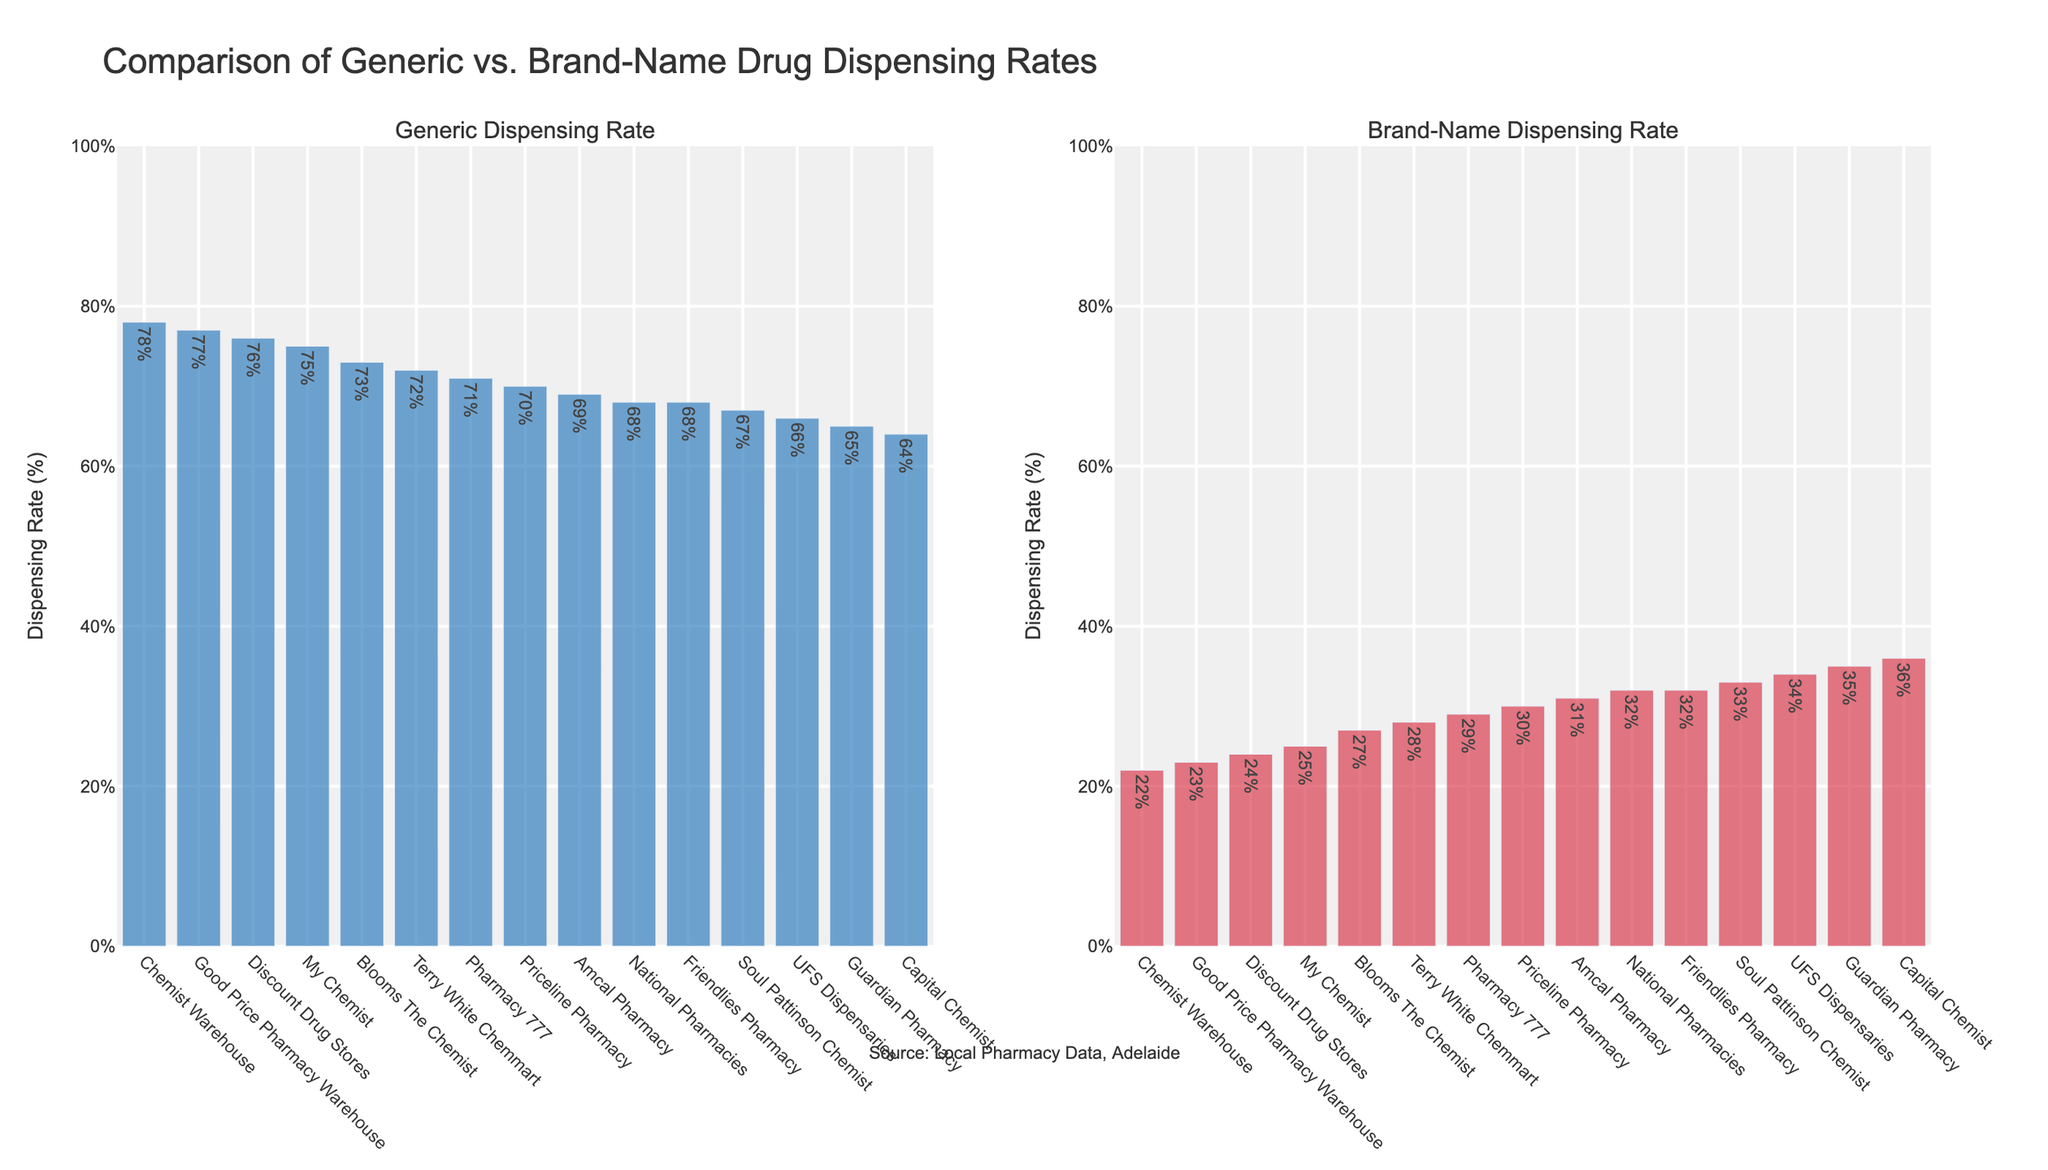What is the pharmacy chain with the highest generic dispensing rate? Look at the first bar in the 'Generic Dispensing Rate' subplot, which represents the highest rate.
Answer: Chemist Warehouse What is the difference in the generic dispensing rates between Chemist Warehouse and Guardian Pharmacy? Chemist Warehouse has a rate of 78% and Guardian Pharmacy has a rate of 65%. The difference is 78% - 65% = 13%.
Answer: 13% Which has a higher brand-name dispensing rate, Amcal Pharmacy or UFS Dispensaries? Compare the heights of the bars in the 'Brand-Name Dispensing Rate' subplot for Amcal Pharmacy and UFS Dispensaries. UFS Dispensaries have a higher rate.
Answer: UFS Dispensaries What is the average generic dispensing rate across all pharmacy chains? Sum all the generic dispensing rates and divide by the number of chains (15). (78+72+70+68+76+65+67+69+71+75+66+64+77+73+68) / 15 = 71%
Answer: 71% Which pharmacy chain has a higher generic dispensing rate than Priceline Pharmacy but a lower rate than Terry White Chemmart? Priceline Pharmacy has a rate of 70% and Terry White Chemmart has a rate of 72%. Find the bar that fits between these rates in the 'Generic Dispensing Rate' subplot, which is Amcal Pharmacy with 69%.
Answer: Amcal Pharmacy What is the total brand-name dispensing rate for Discount Drug Stores, My Chemist, and Good Price Pharmacy Warehouse? Sum the individual brand-name dispensing rates: 24% + 25% + 23% = 72%.
Answer: 72% Is there any pharmacy chain with a brand-name dispensing rate equal to 30%? Examine each bar in the 'Brand-Name Dispensing Rate' subplot to check for a 30% value. Priceline Pharmacy has a brand-name dispensing rate of 30%.
Answer: Yes, Priceline Pharmacy Which pharmacy chain has the lowest overall dispensing rate of brand-name drugs? Look for the shortest bar in the 'Brand-Name Dispensing Rate' subplot. Good Price Pharmacy Warehouse has the lowest rate at 23%.
Answer: Good Price Pharmacy Warehouse Is the brand-name dispensing rate of Blooms The Chemist higher than that of Friendlies Pharmacy? Check the heights of the bars in the 'Brand-Name Dispensing Rate' subplot. Blooms The Chemist has a rate of 27% and Friendlies Pharmacy has a rate of 32%.
Answer: No 